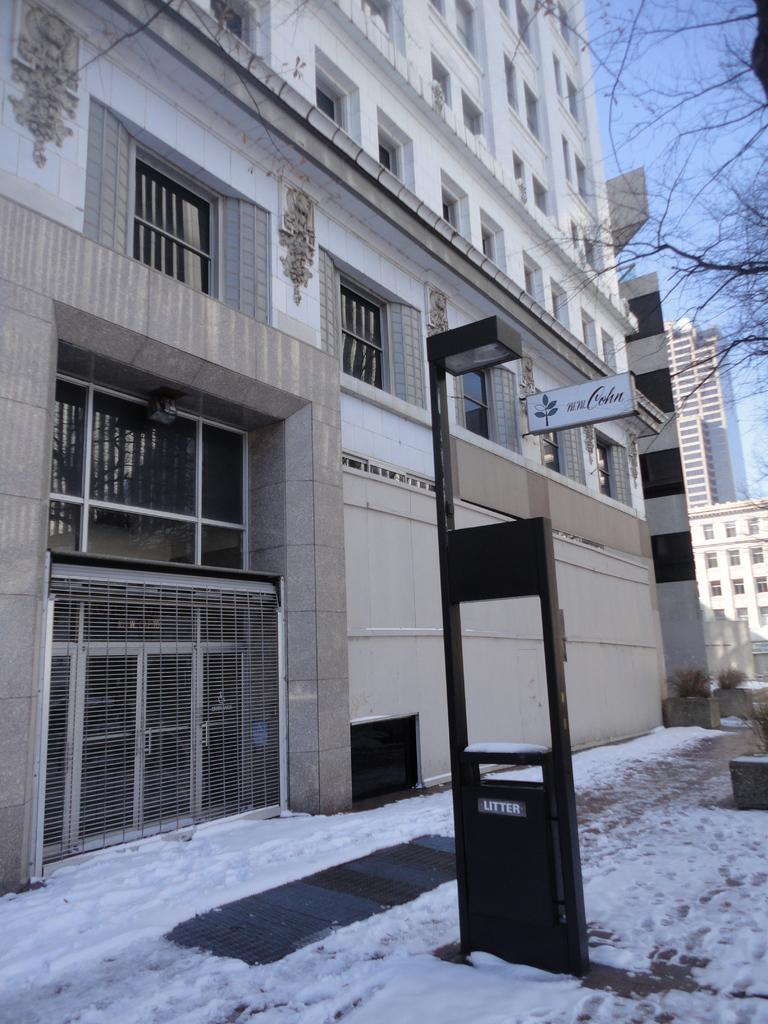What type of structures can be seen in the image? There are buildings in the image. What other natural elements are present in the image? There are trees in the image. What is the weather condition in the image? There is snow visible at the bottom of the image, indicating a snowy condition. What can be seen in the background of the image? There are buildings and the sky visible in the background of the image. What color are the earrings worn by the trees in the image? There are no earrings or any human elements present in the image; it features buildings, trees, snow, and the sky. 